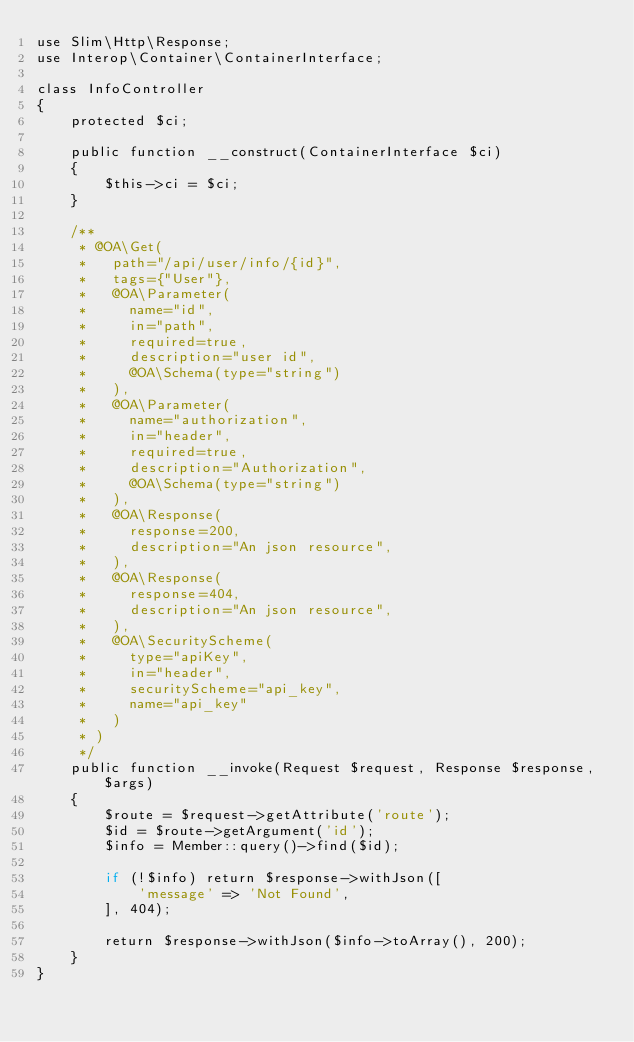Convert code to text. <code><loc_0><loc_0><loc_500><loc_500><_PHP_>use Slim\Http\Response;
use Interop\Container\ContainerInterface;

class InfoController
{
    protected $ci;

    public function __construct(ContainerInterface $ci)
    {
        $this->ci = $ci;
    }

    /**
     * @OA\Get(
     *   path="/api/user/info/{id}",
     *   tags={"User"},
     *   @OA\Parameter(
     *     name="id",
     *     in="path",
     *     required=true,
     *     description="user id",
     *     @OA\Schema(type="string")
     *   ),
     *   @OA\Parameter(
     *     name="authorization",
     *     in="header",
     *     required=true,
     *     description="Authorization",
     *     @OA\Schema(type="string")
     *   ),
     *   @OA\Response(
     *     response=200,
     *     description="An json resource",
     *   ),
     *   @OA\Response(
     *     response=404,
     *     description="An json resource",
     *   ),
     *   @OA\SecurityScheme(
     *     type="apiKey",
     *     in="header",
     *     securityScheme="api_key",
     *     name="api_key"
     *   )
     * )
     */
    public function __invoke(Request $request, Response $response, $args)
    {
        $route = $request->getAttribute('route');
        $id = $route->getArgument('id');
        $info = Member::query()->find($id);

        if (!$info) return $response->withJson([
            'message' => 'Not Found',
        ], 404);

        return $response->withJson($info->toArray(), 200);
    }
}</code> 